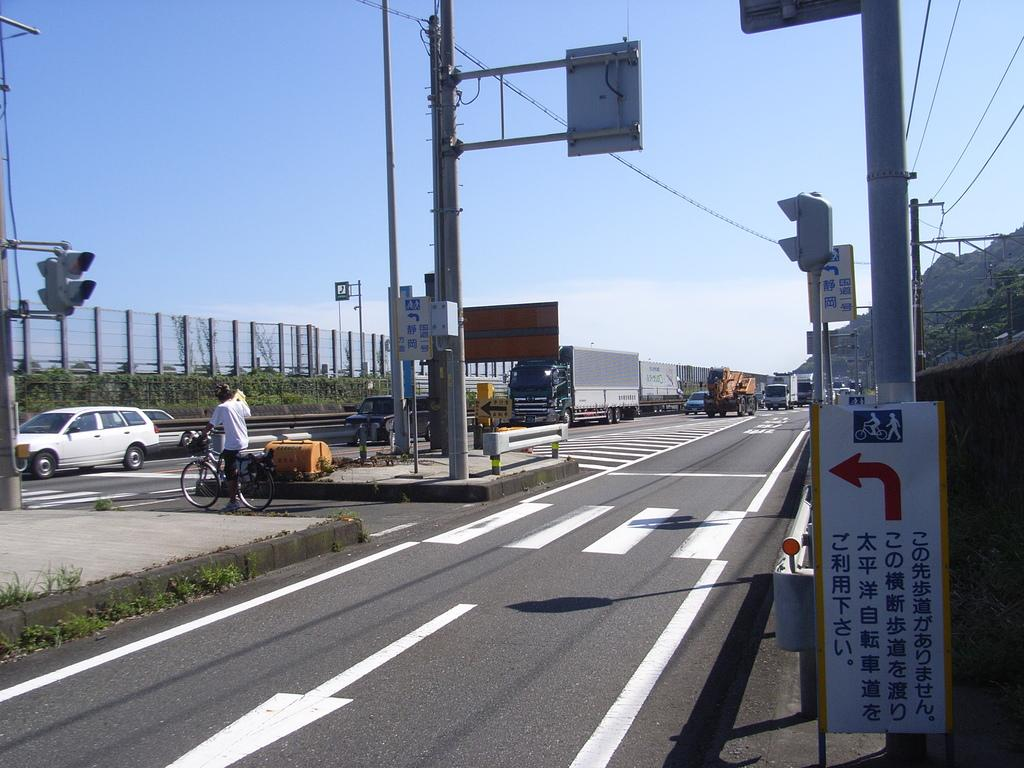What is the main subject in the middle of the image? There is a road in the middle of the image. What is happening on the road? There are vehicles moving on the road. How many ants can be seen carrying leaves on the road in the image? There are no ants or leaves present on the road in the image. What type of horses are visible in the image? There are no horses present in the image. 